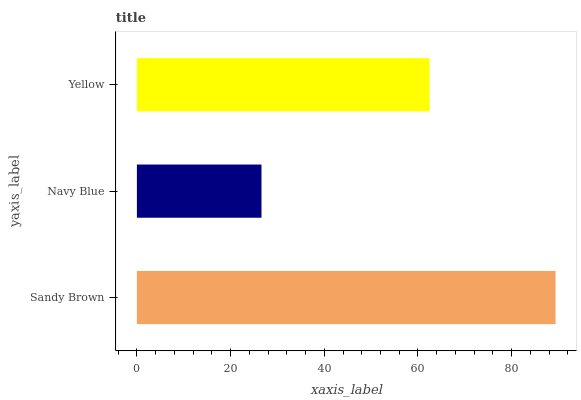Is Navy Blue the minimum?
Answer yes or no. Yes. Is Sandy Brown the maximum?
Answer yes or no. Yes. Is Yellow the minimum?
Answer yes or no. No. Is Yellow the maximum?
Answer yes or no. No. Is Yellow greater than Navy Blue?
Answer yes or no. Yes. Is Navy Blue less than Yellow?
Answer yes or no. Yes. Is Navy Blue greater than Yellow?
Answer yes or no. No. Is Yellow less than Navy Blue?
Answer yes or no. No. Is Yellow the high median?
Answer yes or no. Yes. Is Yellow the low median?
Answer yes or no. Yes. Is Navy Blue the high median?
Answer yes or no. No. Is Sandy Brown the low median?
Answer yes or no. No. 